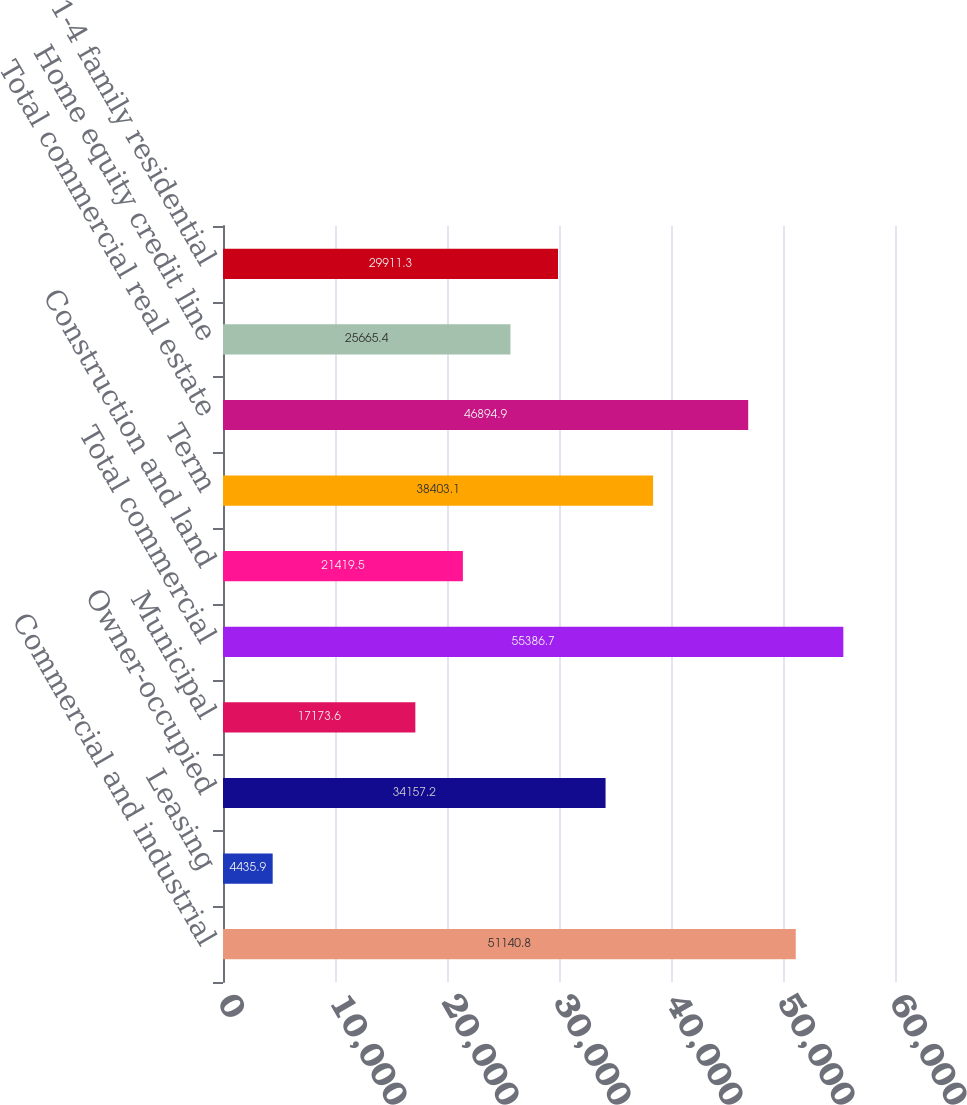Convert chart to OTSL. <chart><loc_0><loc_0><loc_500><loc_500><bar_chart><fcel>Commercial and industrial<fcel>Leasing<fcel>Owner-occupied<fcel>Municipal<fcel>Total commercial<fcel>Construction and land<fcel>Term<fcel>Total commercial real estate<fcel>Home equity credit line<fcel>1-4 family residential<nl><fcel>51140.8<fcel>4435.9<fcel>34157.2<fcel>17173.6<fcel>55386.7<fcel>21419.5<fcel>38403.1<fcel>46894.9<fcel>25665.4<fcel>29911.3<nl></chart> 